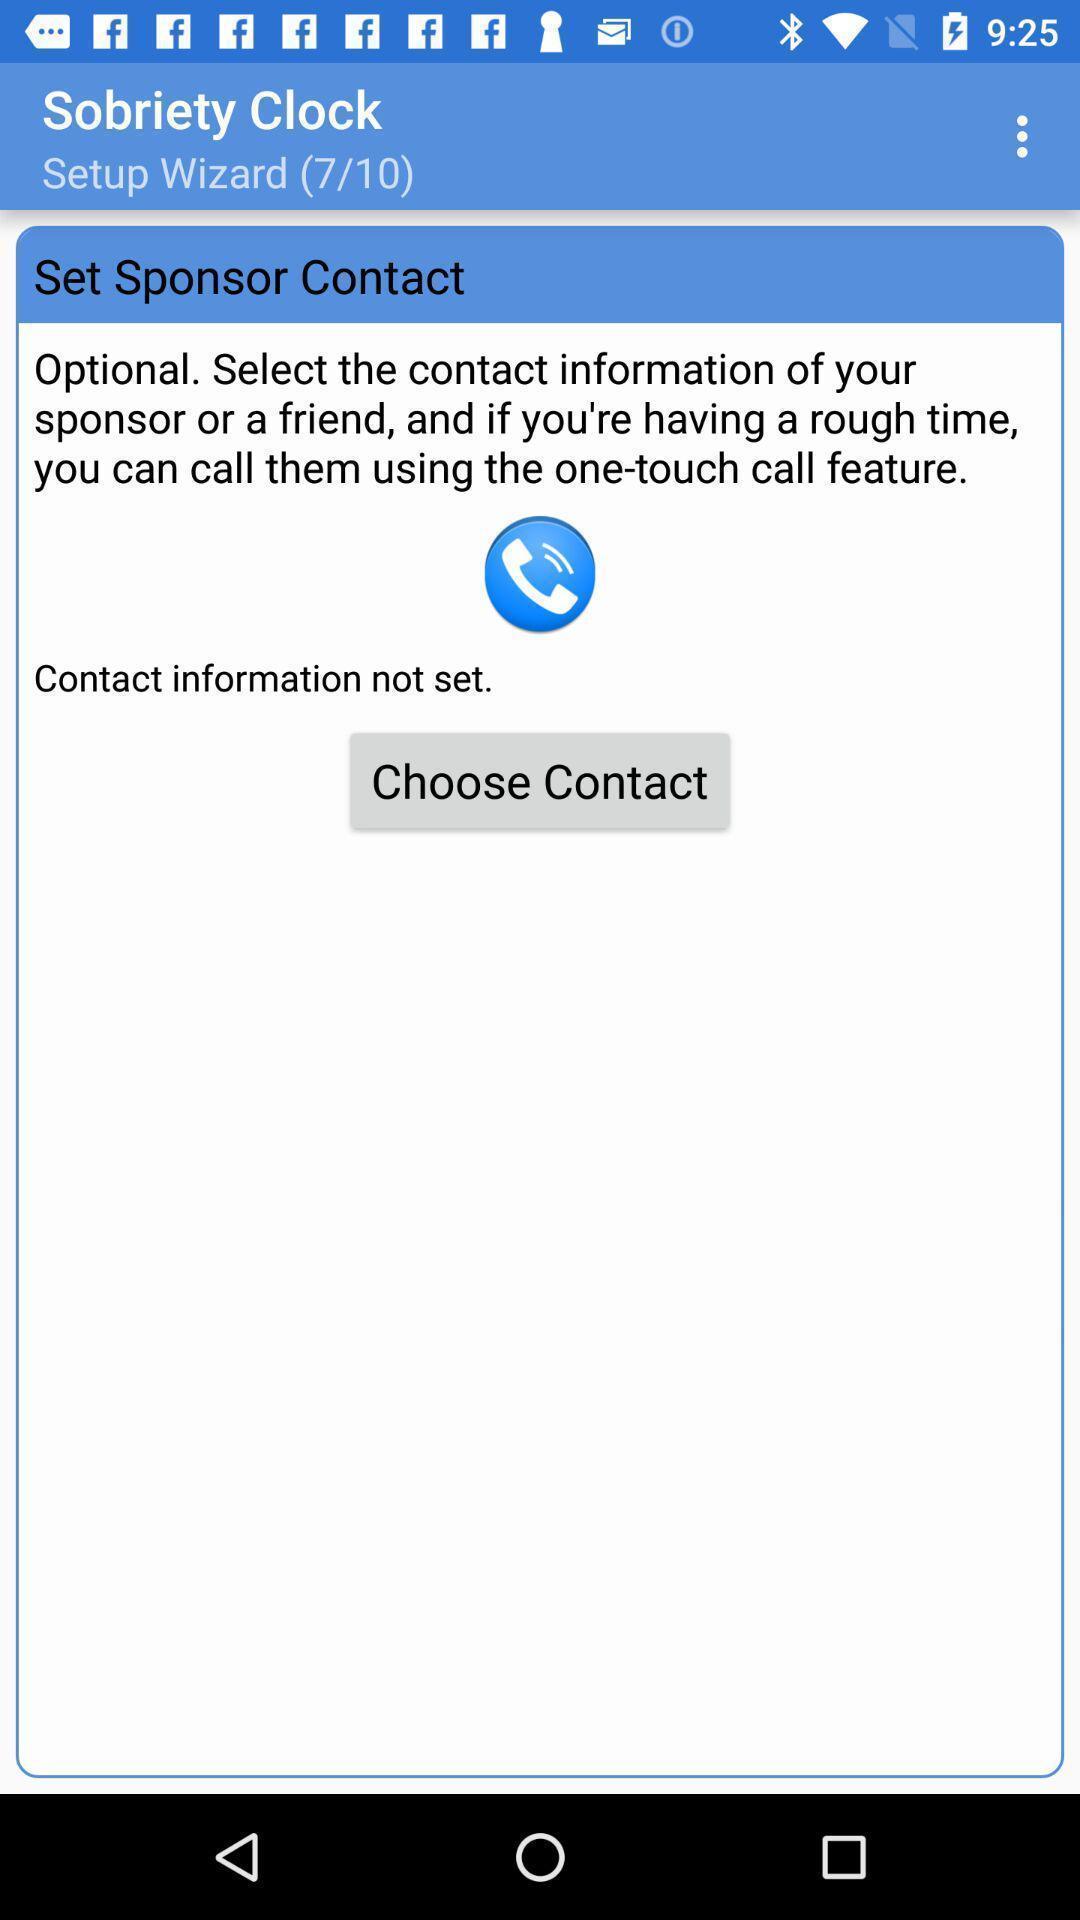Describe the visual elements of this screenshot. Screen shows sobriety contact details. 